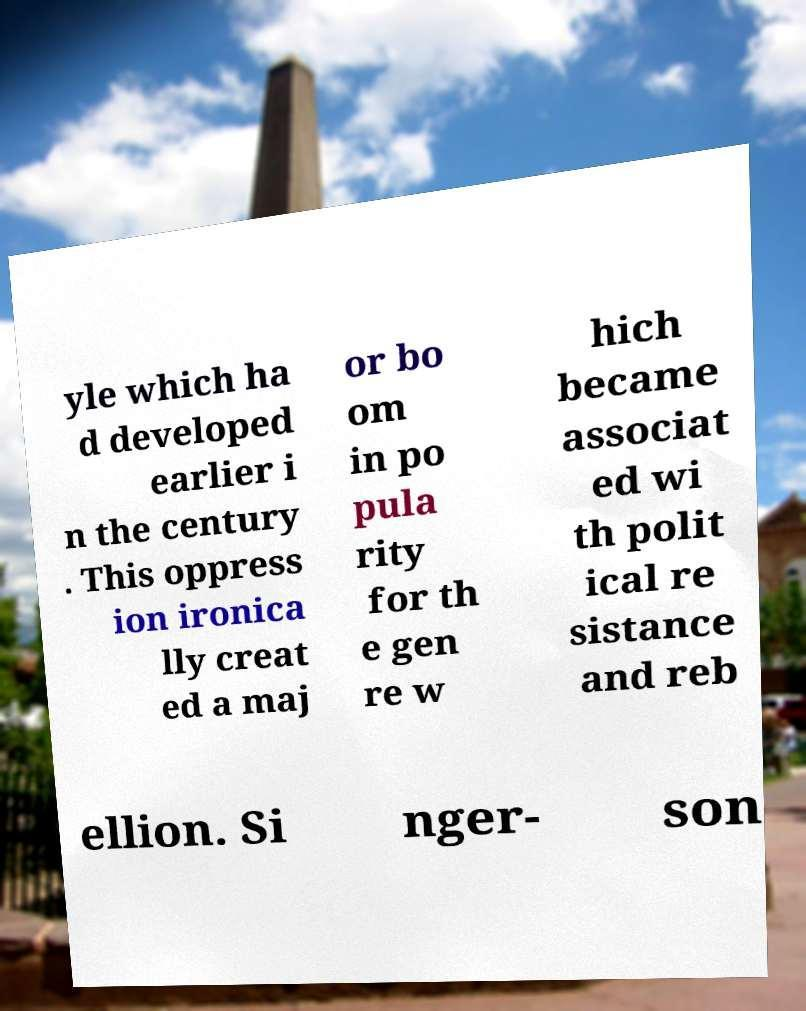Please read and relay the text visible in this image. What does it say? yle which ha d developed earlier i n the century . This oppress ion ironica lly creat ed a maj or bo om in po pula rity for th e gen re w hich became associat ed wi th polit ical re sistance and reb ellion. Si nger- son 